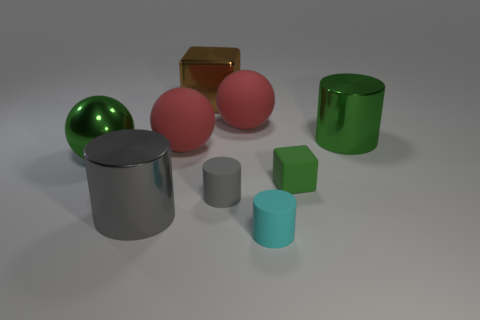Subtract all large matte spheres. How many spheres are left? 1 Subtract all cyan cylinders. How many cylinders are left? 3 Subtract all blue cylinders. Subtract all brown blocks. How many cylinders are left? 4 Subtract all balls. How many objects are left? 6 Add 3 small gray things. How many small gray things are left? 4 Add 5 large green blocks. How many large green blocks exist? 5 Subtract 0 blue cubes. How many objects are left? 9 Subtract all big red objects. Subtract all cyan matte things. How many objects are left? 6 